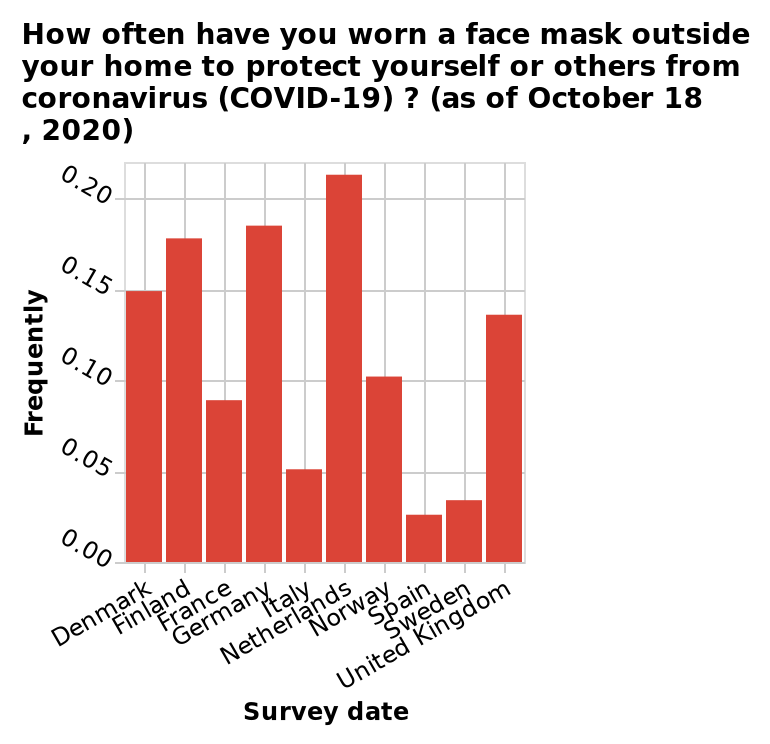<image>
Offer a thorough analysis of the image. Netherlands had the highest mask wearing frequency. Spain had the lowest mask wearing frequency. please describe the details of the chart Here a is a bar plot titled How often have you worn a face mask outside your home to protect yourself or others from coronavirus (COVID-19) ? (as of October 18 , 2020). The x-axis plots Survey date as categorical scale starting with Denmark and ending with United Kingdom while the y-axis measures Frequently with linear scale from 0.00 to 0.20. Is mask wearing consistent across all European countries? No, there is a bipolar distribution of mask wearing across Europe, with some countries having high uptake and others having lower uptake. What does the x-axis indicate in the bar plot? The x-axis represents the survey date as a categorical scale, starting with Denmark and ending with the United Kingdom. 